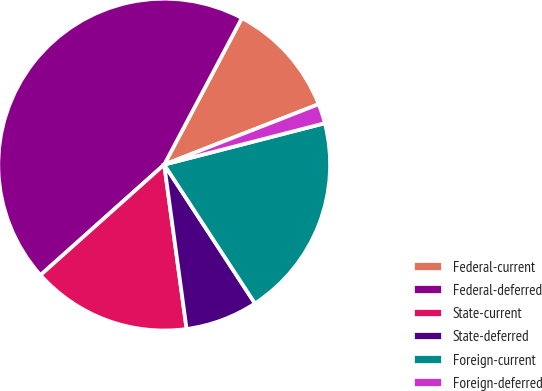<chart> <loc_0><loc_0><loc_500><loc_500><pie_chart><fcel>Federal-current<fcel>Federal-deferred<fcel>State-current<fcel>State-deferred<fcel>Foreign-current<fcel>Foreign-deferred<nl><fcel>11.31%<fcel>44.36%<fcel>15.55%<fcel>7.06%<fcel>19.8%<fcel>1.92%<nl></chart> 